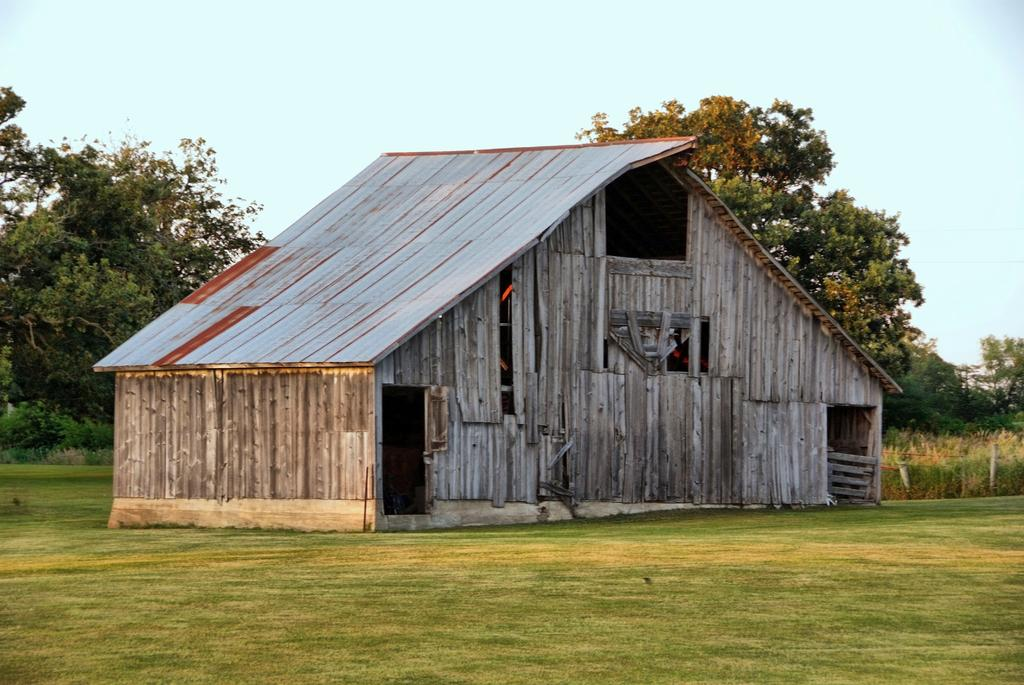What type of outdoor space is visible in the image? There is a lawn in the image. What type of structure is present on the lawn? There is a wooden house in the image. What other natural elements can be seen in the image? There are trees in the image. What is visible in the background of the image? The sky is visible in the background of the image. What type of vacation is being taken in the image? There is no indication of a vacation in the image; it simply shows a lawn, wooden house, trees, and sky. Can you see a mark on the wooden house in the image? There is no mention of a mark on the wooden house in the provided facts, so it cannot be determined from the image. 